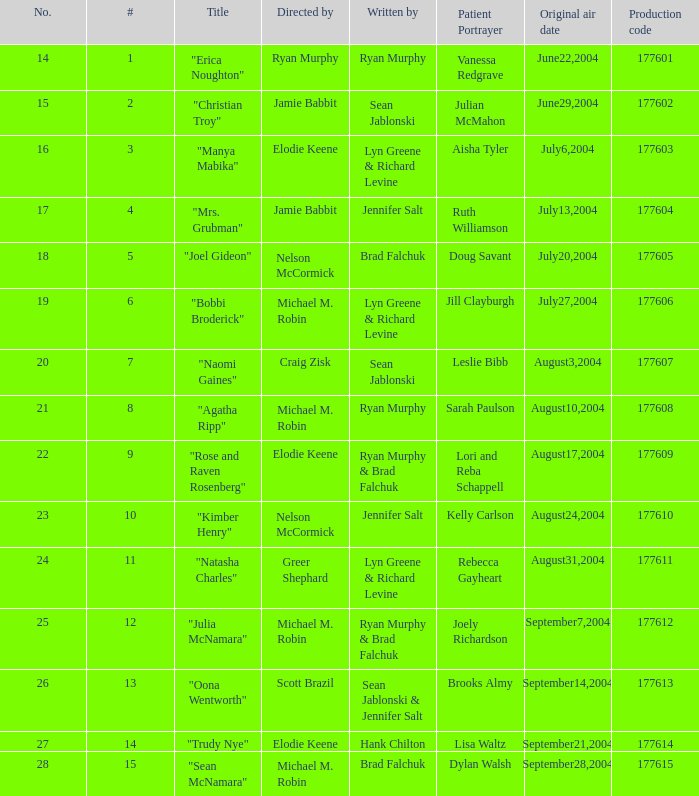Who was the director of the episode with production code 177605? Nelson McCormick. Could you parse the entire table as a dict? {'header': ['No.', '#', 'Title', 'Directed by', 'Written by', 'Patient Portrayer', 'Original air date', 'Production code'], 'rows': [['14', '1', '"Erica Noughton"', 'Ryan Murphy', 'Ryan Murphy', 'Vanessa Redgrave', 'June22,2004', '177601'], ['15', '2', '"Christian Troy"', 'Jamie Babbit', 'Sean Jablonski', 'Julian McMahon', 'June29,2004', '177602'], ['16', '3', '"Manya Mabika"', 'Elodie Keene', 'Lyn Greene & Richard Levine', 'Aisha Tyler', 'July6,2004', '177603'], ['17', '4', '"Mrs. Grubman"', 'Jamie Babbit', 'Jennifer Salt', 'Ruth Williamson', 'July13,2004', '177604'], ['18', '5', '"Joel Gideon"', 'Nelson McCormick', 'Brad Falchuk', 'Doug Savant', 'July20,2004', '177605'], ['19', '6', '"Bobbi Broderick"', 'Michael M. Robin', 'Lyn Greene & Richard Levine', 'Jill Clayburgh', 'July27,2004', '177606'], ['20', '7', '"Naomi Gaines"', 'Craig Zisk', 'Sean Jablonski', 'Leslie Bibb', 'August3,2004', '177607'], ['21', '8', '"Agatha Ripp"', 'Michael M. Robin', 'Ryan Murphy', 'Sarah Paulson', 'August10,2004', '177608'], ['22', '9', '"Rose and Raven Rosenberg"', 'Elodie Keene', 'Ryan Murphy & Brad Falchuk', 'Lori and Reba Schappell', 'August17,2004', '177609'], ['23', '10', '"Kimber Henry"', 'Nelson McCormick', 'Jennifer Salt', 'Kelly Carlson', 'August24,2004', '177610'], ['24', '11', '"Natasha Charles"', 'Greer Shephard', 'Lyn Greene & Richard Levine', 'Rebecca Gayheart', 'August31,2004', '177611'], ['25', '12', '"Julia McNamara"', 'Michael M. Robin', 'Ryan Murphy & Brad Falchuk', 'Joely Richardson', 'September7,2004', '177612'], ['26', '13', '"Oona Wentworth"', 'Scott Brazil', 'Sean Jablonski & Jennifer Salt', 'Brooks Almy', 'September14,2004', '177613'], ['27', '14', '"Trudy Nye"', 'Elodie Keene', 'Hank Chilton', 'Lisa Waltz', 'September21,2004', '177614'], ['28', '15', '"Sean McNamara"', 'Michael M. Robin', 'Brad Falchuk', 'Dylan Walsh', 'September28,2004', '177615']]} 